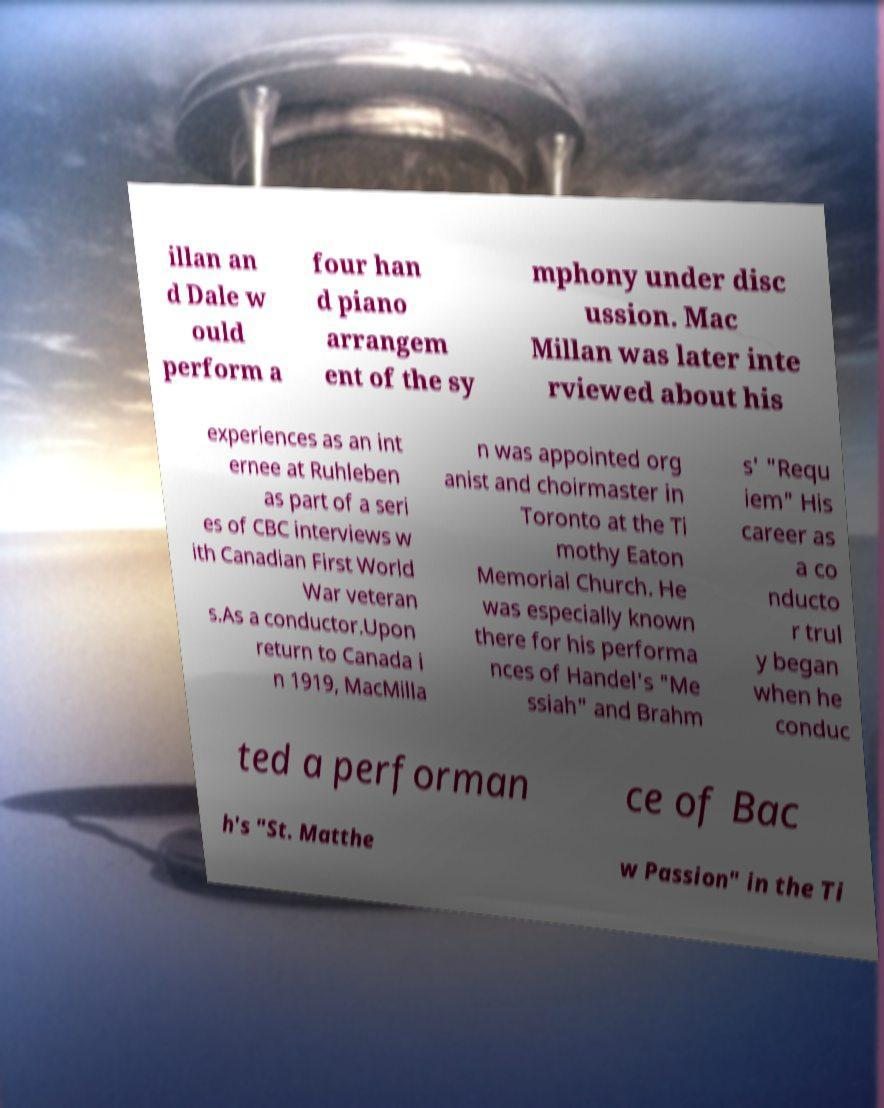There's text embedded in this image that I need extracted. Can you transcribe it verbatim? illan an d Dale w ould perform a four han d piano arrangem ent of the sy mphony under disc ussion. Mac Millan was later inte rviewed about his experiences as an int ernee at Ruhleben as part of a seri es of CBC interviews w ith Canadian First World War veteran s.As a conductor.Upon return to Canada i n 1919, MacMilla n was appointed org anist and choirmaster in Toronto at the Ti mothy Eaton Memorial Church. He was especially known there for his performa nces of Handel's "Me ssiah" and Brahm s' "Requ iem" His career as a co nducto r trul y began when he conduc ted a performan ce of Bac h's "St. Matthe w Passion" in the Ti 